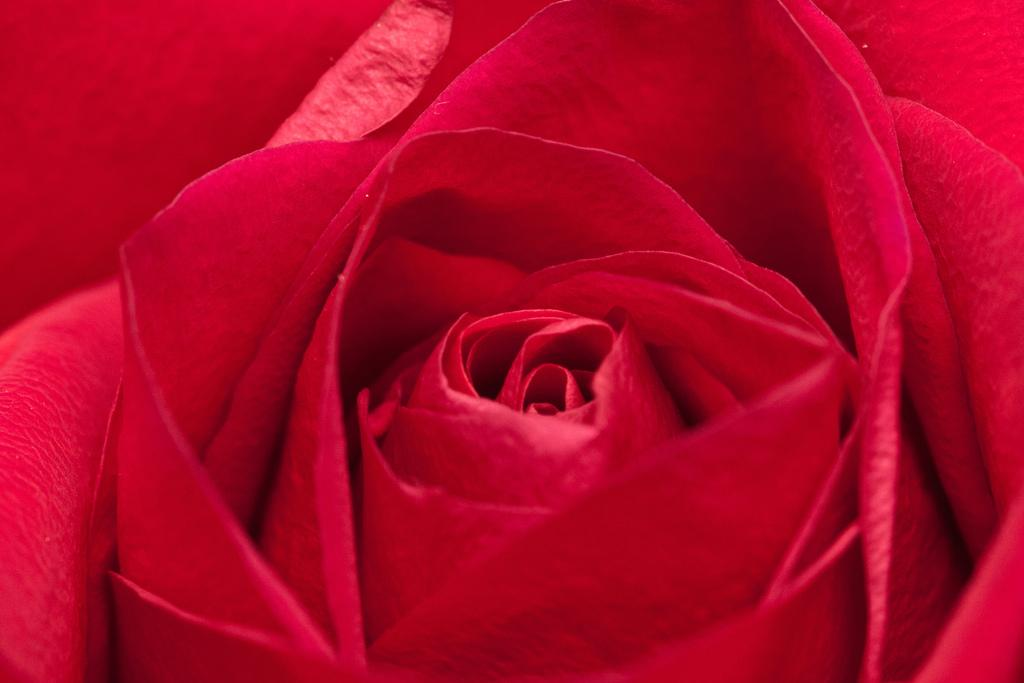What type of flower is in the image? There is a red color flower in the image. How many petals does the flower have? The flower has many petals. What type of oatmeal is being served at the cemetery in the image? There is no cemetery or oatmeal present in the image; it features a red color flower with many petals. 